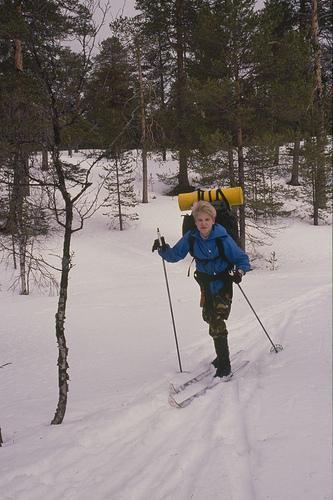How many skis does this person have?
Give a very brief answer. 2. How many arms does she have?
Give a very brief answer. 2. 